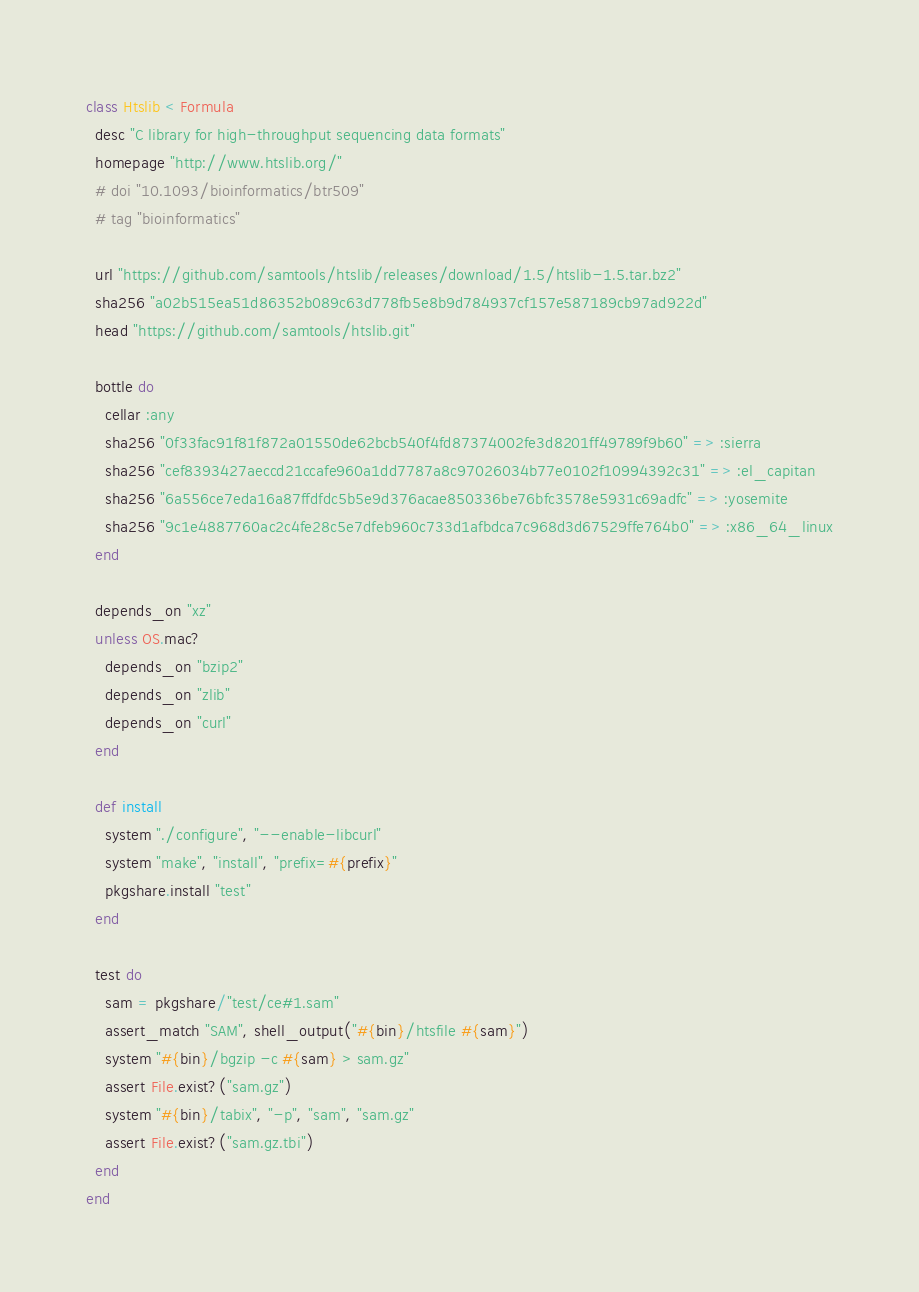<code> <loc_0><loc_0><loc_500><loc_500><_Ruby_>class Htslib < Formula
  desc "C library for high-throughput sequencing data formats"
  homepage "http://www.htslib.org/"
  # doi "10.1093/bioinformatics/btr509"
  # tag "bioinformatics"

  url "https://github.com/samtools/htslib/releases/download/1.5/htslib-1.5.tar.bz2"
  sha256 "a02b515ea51d86352b089c63d778fb5e8b9d784937cf157e587189cb97ad922d"
  head "https://github.com/samtools/htslib.git"

  bottle do
    cellar :any
    sha256 "0f33fac91f81f872a01550de62bcb540f4fd87374002fe3d8201ff49789f9b60" => :sierra
    sha256 "cef8393427aeccd21ccafe960a1dd7787a8c97026034b77e0102f10994392c31" => :el_capitan
    sha256 "6a556ce7eda16a87ffdfdc5b5e9d376acae850336be76bfc3578e5931c69adfc" => :yosemite
    sha256 "9c1e4887760ac2c4fe28c5e7dfeb960c733d1afbdca7c968d3d67529ffe764b0" => :x86_64_linux
  end

  depends_on "xz"
  unless OS.mac?
    depends_on "bzip2"
    depends_on "zlib"
    depends_on "curl"
  end

  def install
    system "./configure", "--enable-libcurl"
    system "make", "install", "prefix=#{prefix}"
    pkgshare.install "test"
  end

  test do
    sam = pkgshare/"test/ce#1.sam"
    assert_match "SAM", shell_output("#{bin}/htsfile #{sam}")
    system "#{bin}/bgzip -c #{sam} > sam.gz"
    assert File.exist?("sam.gz")
    system "#{bin}/tabix", "-p", "sam", "sam.gz"
    assert File.exist?("sam.gz.tbi")
  end
end
</code> 